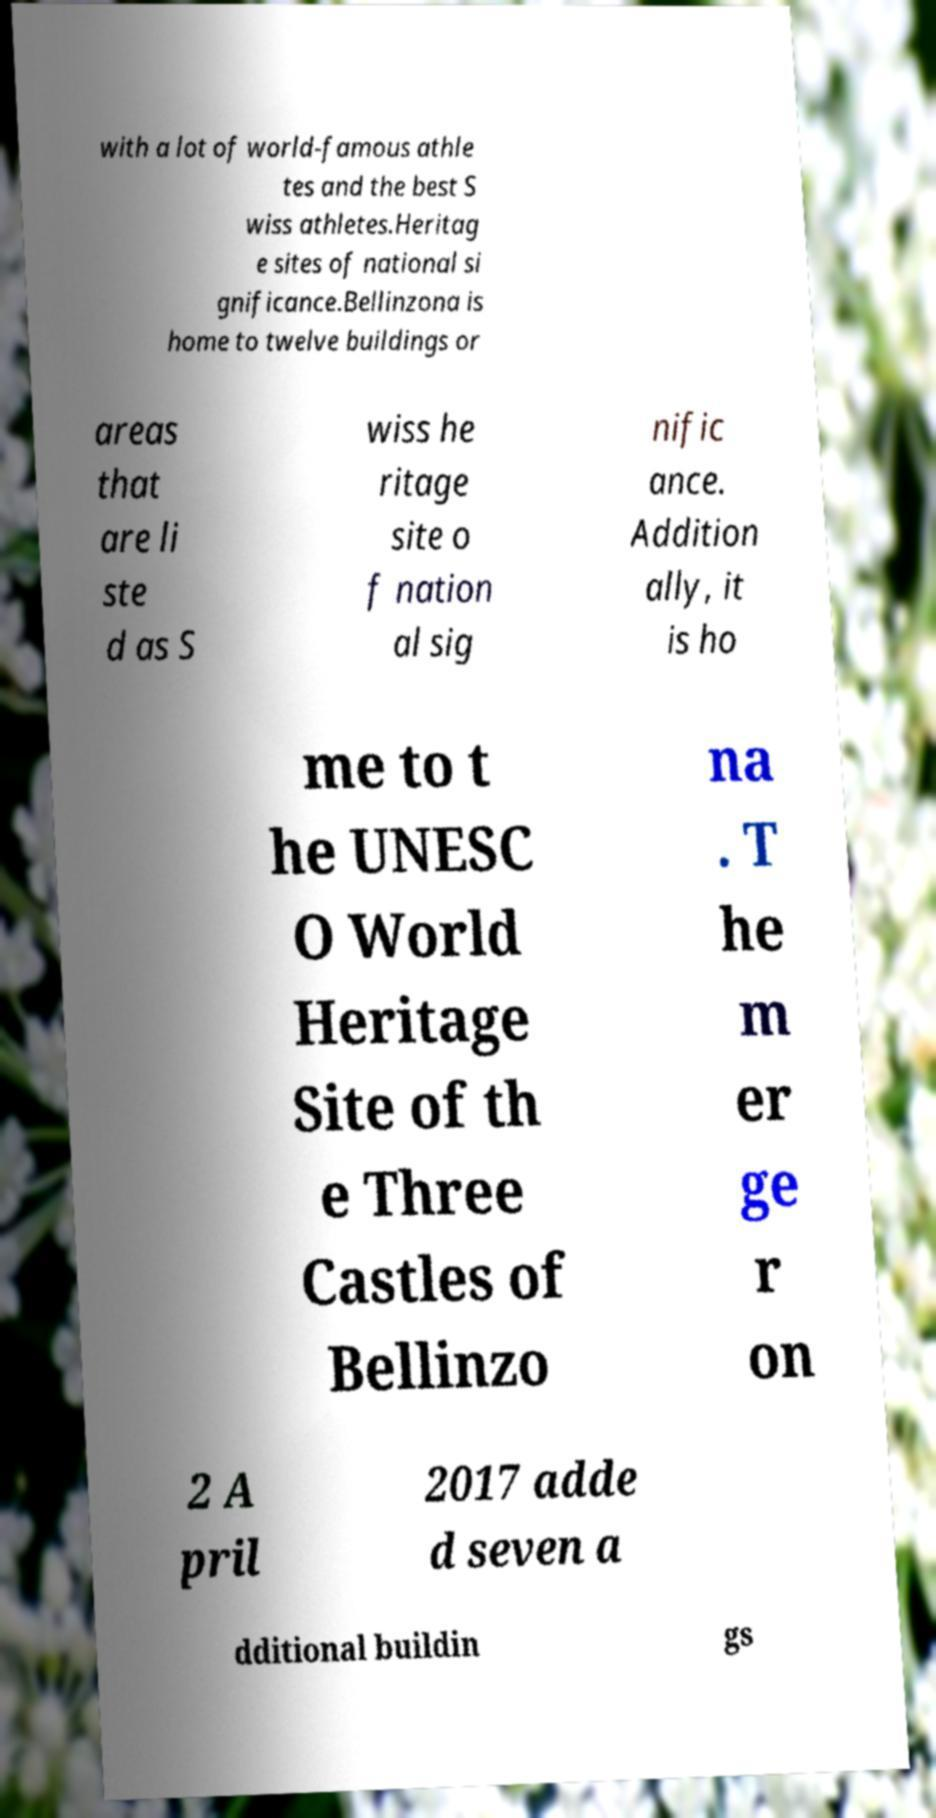I need the written content from this picture converted into text. Can you do that? with a lot of world-famous athle tes and the best S wiss athletes.Heritag e sites of national si gnificance.Bellinzona is home to twelve buildings or areas that are li ste d as S wiss he ritage site o f nation al sig nific ance. Addition ally, it is ho me to t he UNESC O World Heritage Site of th e Three Castles of Bellinzo na . T he m er ge r on 2 A pril 2017 adde d seven a dditional buildin gs 